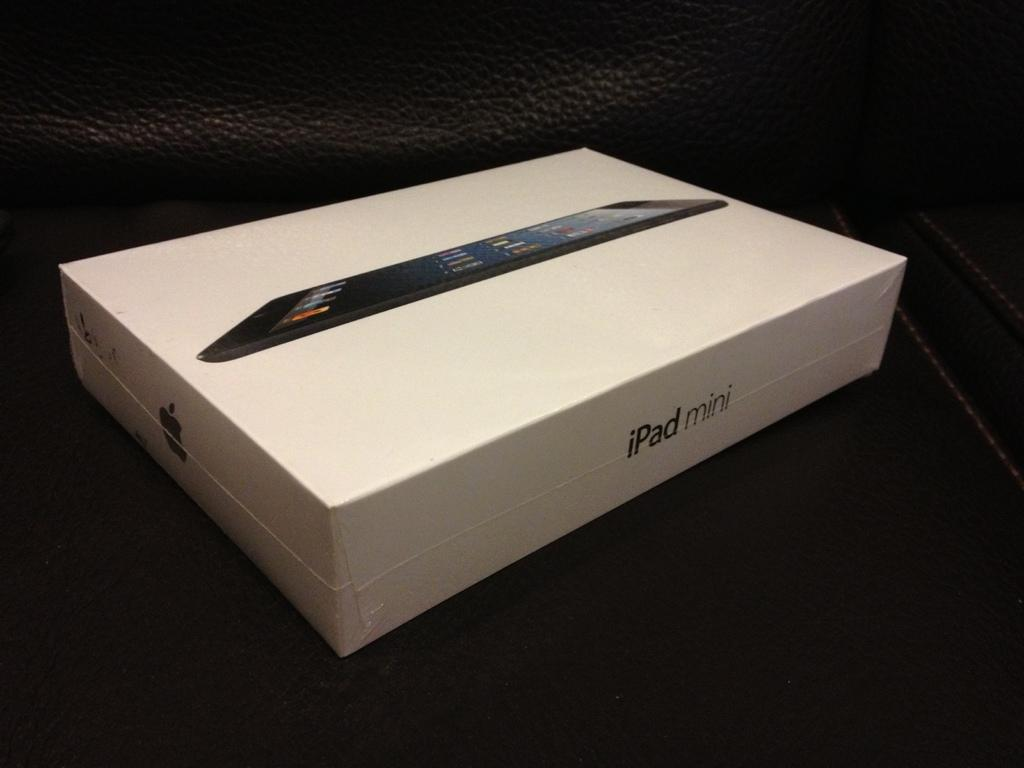<image>
Share a concise interpretation of the image provided. A white box of an iPad mini with a picture of it on the top of the box. 